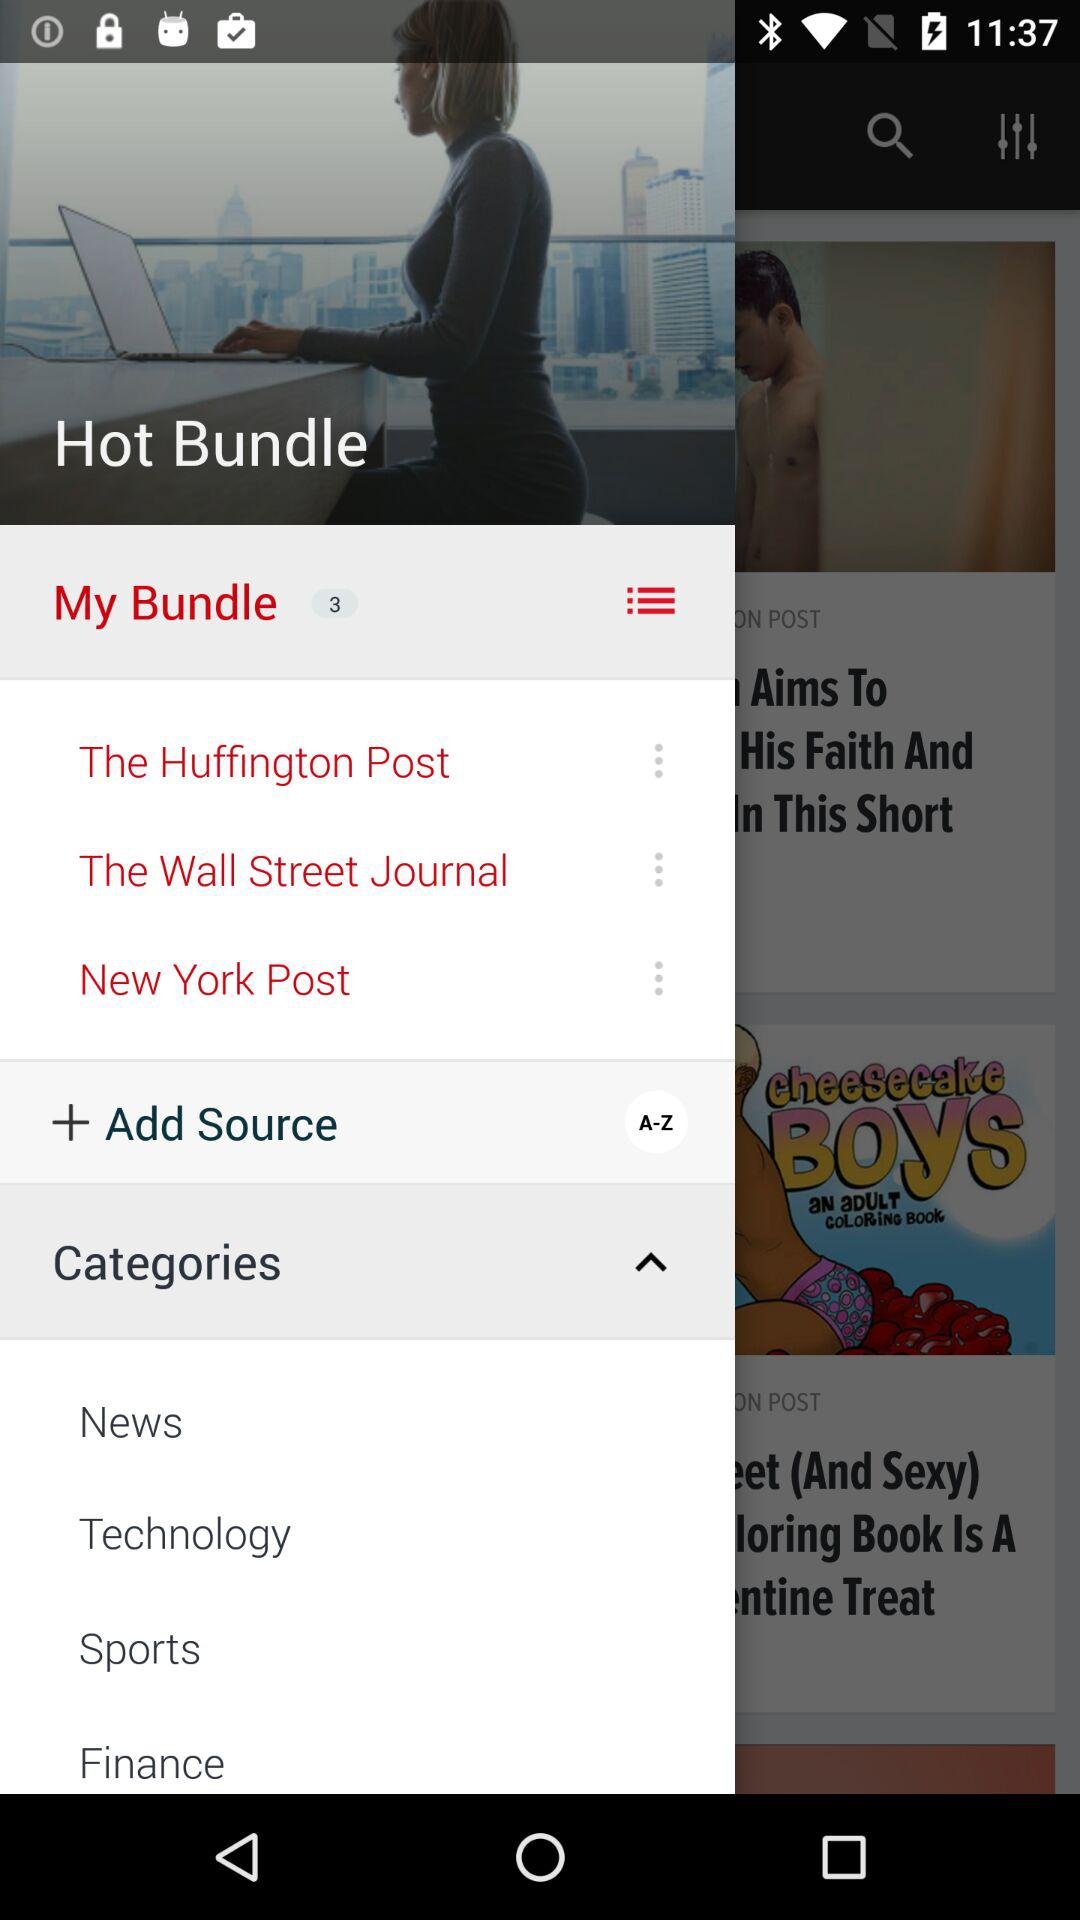How many notifications are in "My Bundle"? There are 3 notifications. 